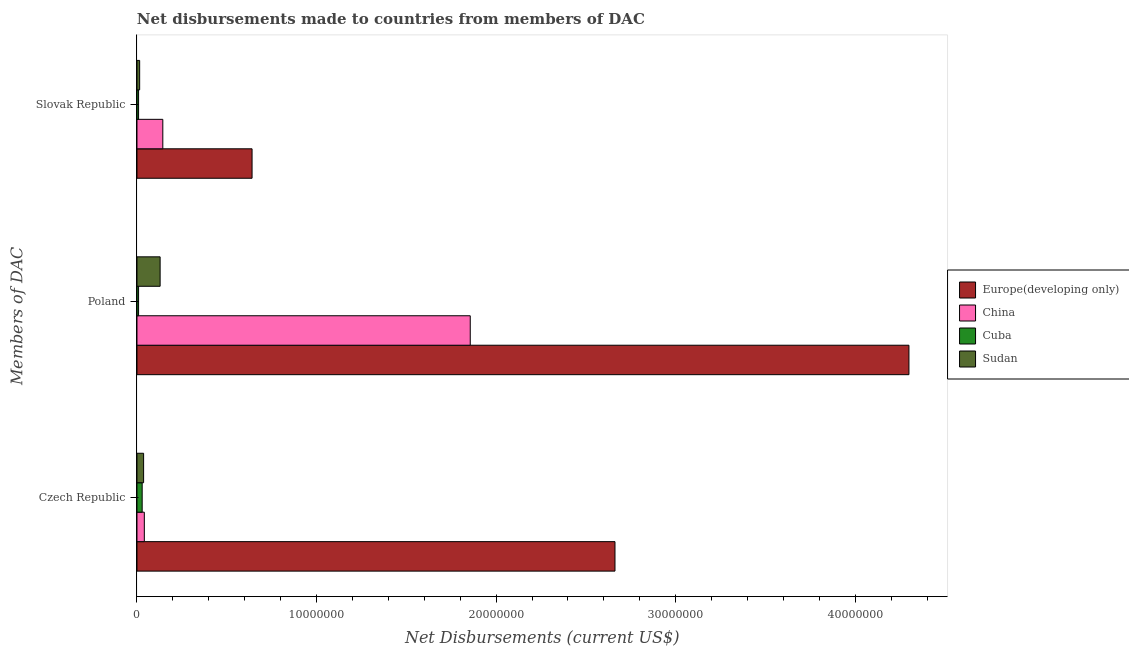How many groups of bars are there?
Ensure brevity in your answer.  3. Are the number of bars per tick equal to the number of legend labels?
Provide a succinct answer. Yes. What is the net disbursements made by poland in Sudan?
Offer a terse response. 1.29e+06. Across all countries, what is the maximum net disbursements made by slovak republic?
Your response must be concise. 6.41e+06. Across all countries, what is the minimum net disbursements made by czech republic?
Your response must be concise. 2.90e+05. In which country was the net disbursements made by czech republic maximum?
Provide a succinct answer. Europe(developing only). In which country was the net disbursements made by czech republic minimum?
Ensure brevity in your answer.  Cuba. What is the total net disbursements made by slovak republic in the graph?
Provide a succinct answer. 8.09e+06. What is the difference between the net disbursements made by slovak republic in Cuba and that in China?
Offer a terse response. -1.35e+06. What is the difference between the net disbursements made by slovak republic in Cuba and the net disbursements made by czech republic in China?
Provide a succinct answer. -3.20e+05. What is the average net disbursements made by slovak republic per country?
Your answer should be compact. 2.02e+06. What is the difference between the net disbursements made by poland and net disbursements made by czech republic in Sudan?
Your answer should be compact. 9.20e+05. In how many countries, is the net disbursements made by czech republic greater than 16000000 US$?
Provide a short and direct response. 1. What is the ratio of the net disbursements made by poland in China to that in Sudan?
Ensure brevity in your answer.  14.39. Is the net disbursements made by poland in China less than that in Sudan?
Give a very brief answer. No. What is the difference between the highest and the second highest net disbursements made by slovak republic?
Give a very brief answer. 4.97e+06. What is the difference between the highest and the lowest net disbursements made by poland?
Your answer should be compact. 4.29e+07. Is the sum of the net disbursements made by slovak republic in Sudan and China greater than the maximum net disbursements made by czech republic across all countries?
Make the answer very short. No. What does the 1st bar from the top in Poland represents?
Make the answer very short. Sudan. What does the 1st bar from the bottom in Slovak Republic represents?
Ensure brevity in your answer.  Europe(developing only). Is it the case that in every country, the sum of the net disbursements made by czech republic and net disbursements made by poland is greater than the net disbursements made by slovak republic?
Your response must be concise. Yes. How many countries are there in the graph?
Ensure brevity in your answer.  4. What is the difference between two consecutive major ticks on the X-axis?
Keep it short and to the point. 1.00e+07. Are the values on the major ticks of X-axis written in scientific E-notation?
Keep it short and to the point. No. Does the graph contain any zero values?
Keep it short and to the point. No. Does the graph contain grids?
Make the answer very short. No. How many legend labels are there?
Your answer should be very brief. 4. How are the legend labels stacked?
Make the answer very short. Vertical. What is the title of the graph?
Offer a terse response. Net disbursements made to countries from members of DAC. Does "Sierra Leone" appear as one of the legend labels in the graph?
Your response must be concise. No. What is the label or title of the X-axis?
Keep it short and to the point. Net Disbursements (current US$). What is the label or title of the Y-axis?
Your response must be concise. Members of DAC. What is the Net Disbursements (current US$) of Europe(developing only) in Czech Republic?
Offer a terse response. 2.66e+07. What is the Net Disbursements (current US$) in China in Czech Republic?
Offer a very short reply. 4.10e+05. What is the Net Disbursements (current US$) in Cuba in Czech Republic?
Your response must be concise. 2.90e+05. What is the Net Disbursements (current US$) of Europe(developing only) in Poland?
Your response must be concise. 4.30e+07. What is the Net Disbursements (current US$) in China in Poland?
Your response must be concise. 1.86e+07. What is the Net Disbursements (current US$) in Cuba in Poland?
Your response must be concise. 9.00e+04. What is the Net Disbursements (current US$) in Sudan in Poland?
Ensure brevity in your answer.  1.29e+06. What is the Net Disbursements (current US$) of Europe(developing only) in Slovak Republic?
Offer a terse response. 6.41e+06. What is the Net Disbursements (current US$) of China in Slovak Republic?
Offer a terse response. 1.44e+06. Across all Members of DAC, what is the maximum Net Disbursements (current US$) of Europe(developing only)?
Your answer should be very brief. 4.30e+07. Across all Members of DAC, what is the maximum Net Disbursements (current US$) in China?
Ensure brevity in your answer.  1.86e+07. Across all Members of DAC, what is the maximum Net Disbursements (current US$) in Cuba?
Your answer should be compact. 2.90e+05. Across all Members of DAC, what is the maximum Net Disbursements (current US$) of Sudan?
Your response must be concise. 1.29e+06. Across all Members of DAC, what is the minimum Net Disbursements (current US$) in Europe(developing only)?
Offer a terse response. 6.41e+06. Across all Members of DAC, what is the minimum Net Disbursements (current US$) of Cuba?
Keep it short and to the point. 9.00e+04. What is the total Net Disbursements (current US$) of Europe(developing only) in the graph?
Give a very brief answer. 7.60e+07. What is the total Net Disbursements (current US$) of China in the graph?
Ensure brevity in your answer.  2.04e+07. What is the total Net Disbursements (current US$) of Cuba in the graph?
Provide a succinct answer. 4.70e+05. What is the total Net Disbursements (current US$) of Sudan in the graph?
Your answer should be compact. 1.81e+06. What is the difference between the Net Disbursements (current US$) in Europe(developing only) in Czech Republic and that in Poland?
Keep it short and to the point. -1.64e+07. What is the difference between the Net Disbursements (current US$) in China in Czech Republic and that in Poland?
Your answer should be very brief. -1.82e+07. What is the difference between the Net Disbursements (current US$) of Sudan in Czech Republic and that in Poland?
Offer a very short reply. -9.20e+05. What is the difference between the Net Disbursements (current US$) of Europe(developing only) in Czech Republic and that in Slovak Republic?
Offer a terse response. 2.02e+07. What is the difference between the Net Disbursements (current US$) in China in Czech Republic and that in Slovak Republic?
Ensure brevity in your answer.  -1.03e+06. What is the difference between the Net Disbursements (current US$) of Cuba in Czech Republic and that in Slovak Republic?
Your response must be concise. 2.00e+05. What is the difference between the Net Disbursements (current US$) in Europe(developing only) in Poland and that in Slovak Republic?
Ensure brevity in your answer.  3.66e+07. What is the difference between the Net Disbursements (current US$) of China in Poland and that in Slovak Republic?
Offer a very short reply. 1.71e+07. What is the difference between the Net Disbursements (current US$) in Sudan in Poland and that in Slovak Republic?
Your answer should be very brief. 1.14e+06. What is the difference between the Net Disbursements (current US$) in Europe(developing only) in Czech Republic and the Net Disbursements (current US$) in China in Poland?
Your answer should be compact. 8.06e+06. What is the difference between the Net Disbursements (current US$) of Europe(developing only) in Czech Republic and the Net Disbursements (current US$) of Cuba in Poland?
Provide a succinct answer. 2.65e+07. What is the difference between the Net Disbursements (current US$) of Europe(developing only) in Czech Republic and the Net Disbursements (current US$) of Sudan in Poland?
Your response must be concise. 2.53e+07. What is the difference between the Net Disbursements (current US$) in China in Czech Republic and the Net Disbursements (current US$) in Sudan in Poland?
Make the answer very short. -8.80e+05. What is the difference between the Net Disbursements (current US$) in Cuba in Czech Republic and the Net Disbursements (current US$) in Sudan in Poland?
Give a very brief answer. -1.00e+06. What is the difference between the Net Disbursements (current US$) of Europe(developing only) in Czech Republic and the Net Disbursements (current US$) of China in Slovak Republic?
Offer a very short reply. 2.52e+07. What is the difference between the Net Disbursements (current US$) of Europe(developing only) in Czech Republic and the Net Disbursements (current US$) of Cuba in Slovak Republic?
Provide a succinct answer. 2.65e+07. What is the difference between the Net Disbursements (current US$) of Europe(developing only) in Czech Republic and the Net Disbursements (current US$) of Sudan in Slovak Republic?
Keep it short and to the point. 2.65e+07. What is the difference between the Net Disbursements (current US$) in China in Czech Republic and the Net Disbursements (current US$) in Cuba in Slovak Republic?
Provide a short and direct response. 3.20e+05. What is the difference between the Net Disbursements (current US$) in China in Czech Republic and the Net Disbursements (current US$) in Sudan in Slovak Republic?
Ensure brevity in your answer.  2.60e+05. What is the difference between the Net Disbursements (current US$) in Europe(developing only) in Poland and the Net Disbursements (current US$) in China in Slovak Republic?
Provide a short and direct response. 4.16e+07. What is the difference between the Net Disbursements (current US$) in Europe(developing only) in Poland and the Net Disbursements (current US$) in Cuba in Slovak Republic?
Your answer should be compact. 4.29e+07. What is the difference between the Net Disbursements (current US$) of Europe(developing only) in Poland and the Net Disbursements (current US$) of Sudan in Slovak Republic?
Keep it short and to the point. 4.28e+07. What is the difference between the Net Disbursements (current US$) of China in Poland and the Net Disbursements (current US$) of Cuba in Slovak Republic?
Make the answer very short. 1.85e+07. What is the difference between the Net Disbursements (current US$) of China in Poland and the Net Disbursements (current US$) of Sudan in Slovak Republic?
Keep it short and to the point. 1.84e+07. What is the difference between the Net Disbursements (current US$) of Cuba in Poland and the Net Disbursements (current US$) of Sudan in Slovak Republic?
Keep it short and to the point. -6.00e+04. What is the average Net Disbursements (current US$) of Europe(developing only) per Members of DAC?
Provide a succinct answer. 2.53e+07. What is the average Net Disbursements (current US$) of China per Members of DAC?
Give a very brief answer. 6.80e+06. What is the average Net Disbursements (current US$) in Cuba per Members of DAC?
Offer a terse response. 1.57e+05. What is the average Net Disbursements (current US$) in Sudan per Members of DAC?
Ensure brevity in your answer.  6.03e+05. What is the difference between the Net Disbursements (current US$) of Europe(developing only) and Net Disbursements (current US$) of China in Czech Republic?
Your response must be concise. 2.62e+07. What is the difference between the Net Disbursements (current US$) of Europe(developing only) and Net Disbursements (current US$) of Cuba in Czech Republic?
Ensure brevity in your answer.  2.63e+07. What is the difference between the Net Disbursements (current US$) of Europe(developing only) and Net Disbursements (current US$) of Sudan in Czech Republic?
Give a very brief answer. 2.62e+07. What is the difference between the Net Disbursements (current US$) in China and Net Disbursements (current US$) in Cuba in Czech Republic?
Provide a short and direct response. 1.20e+05. What is the difference between the Net Disbursements (current US$) of Cuba and Net Disbursements (current US$) of Sudan in Czech Republic?
Keep it short and to the point. -8.00e+04. What is the difference between the Net Disbursements (current US$) of Europe(developing only) and Net Disbursements (current US$) of China in Poland?
Provide a succinct answer. 2.44e+07. What is the difference between the Net Disbursements (current US$) in Europe(developing only) and Net Disbursements (current US$) in Cuba in Poland?
Provide a succinct answer. 4.29e+07. What is the difference between the Net Disbursements (current US$) of Europe(developing only) and Net Disbursements (current US$) of Sudan in Poland?
Give a very brief answer. 4.17e+07. What is the difference between the Net Disbursements (current US$) of China and Net Disbursements (current US$) of Cuba in Poland?
Provide a succinct answer. 1.85e+07. What is the difference between the Net Disbursements (current US$) in China and Net Disbursements (current US$) in Sudan in Poland?
Keep it short and to the point. 1.73e+07. What is the difference between the Net Disbursements (current US$) of Cuba and Net Disbursements (current US$) of Sudan in Poland?
Provide a short and direct response. -1.20e+06. What is the difference between the Net Disbursements (current US$) in Europe(developing only) and Net Disbursements (current US$) in China in Slovak Republic?
Your response must be concise. 4.97e+06. What is the difference between the Net Disbursements (current US$) in Europe(developing only) and Net Disbursements (current US$) in Cuba in Slovak Republic?
Offer a terse response. 6.32e+06. What is the difference between the Net Disbursements (current US$) in Europe(developing only) and Net Disbursements (current US$) in Sudan in Slovak Republic?
Keep it short and to the point. 6.26e+06. What is the difference between the Net Disbursements (current US$) in China and Net Disbursements (current US$) in Cuba in Slovak Republic?
Offer a very short reply. 1.35e+06. What is the difference between the Net Disbursements (current US$) in China and Net Disbursements (current US$) in Sudan in Slovak Republic?
Ensure brevity in your answer.  1.29e+06. What is the ratio of the Net Disbursements (current US$) in Europe(developing only) in Czech Republic to that in Poland?
Your response must be concise. 0.62. What is the ratio of the Net Disbursements (current US$) of China in Czech Republic to that in Poland?
Your answer should be compact. 0.02. What is the ratio of the Net Disbursements (current US$) of Cuba in Czech Republic to that in Poland?
Give a very brief answer. 3.22. What is the ratio of the Net Disbursements (current US$) in Sudan in Czech Republic to that in Poland?
Offer a terse response. 0.29. What is the ratio of the Net Disbursements (current US$) in Europe(developing only) in Czech Republic to that in Slovak Republic?
Your answer should be very brief. 4.15. What is the ratio of the Net Disbursements (current US$) in China in Czech Republic to that in Slovak Republic?
Keep it short and to the point. 0.28. What is the ratio of the Net Disbursements (current US$) in Cuba in Czech Republic to that in Slovak Republic?
Provide a short and direct response. 3.22. What is the ratio of the Net Disbursements (current US$) in Sudan in Czech Republic to that in Slovak Republic?
Provide a short and direct response. 2.47. What is the ratio of the Net Disbursements (current US$) of Europe(developing only) in Poland to that in Slovak Republic?
Give a very brief answer. 6.71. What is the ratio of the Net Disbursements (current US$) in China in Poland to that in Slovak Republic?
Make the answer very short. 12.89. What is the ratio of the Net Disbursements (current US$) of Cuba in Poland to that in Slovak Republic?
Your answer should be compact. 1. What is the difference between the highest and the second highest Net Disbursements (current US$) in Europe(developing only)?
Provide a succinct answer. 1.64e+07. What is the difference between the highest and the second highest Net Disbursements (current US$) of China?
Make the answer very short. 1.71e+07. What is the difference between the highest and the second highest Net Disbursements (current US$) in Cuba?
Provide a succinct answer. 2.00e+05. What is the difference between the highest and the second highest Net Disbursements (current US$) of Sudan?
Provide a succinct answer. 9.20e+05. What is the difference between the highest and the lowest Net Disbursements (current US$) in Europe(developing only)?
Your answer should be very brief. 3.66e+07. What is the difference between the highest and the lowest Net Disbursements (current US$) in China?
Your response must be concise. 1.82e+07. What is the difference between the highest and the lowest Net Disbursements (current US$) of Cuba?
Make the answer very short. 2.00e+05. What is the difference between the highest and the lowest Net Disbursements (current US$) in Sudan?
Keep it short and to the point. 1.14e+06. 